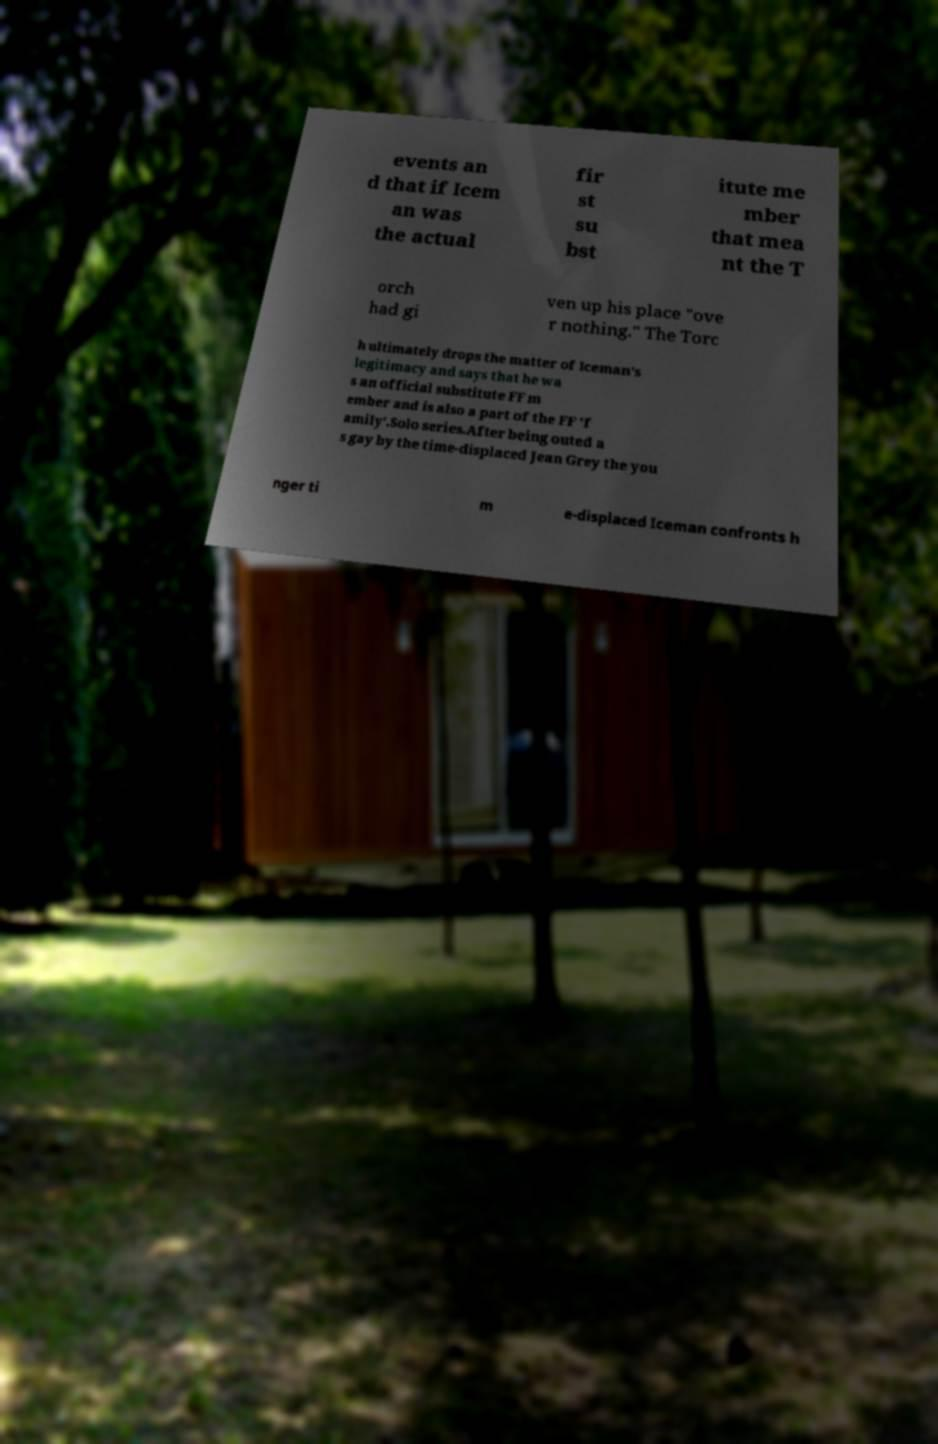Could you assist in decoding the text presented in this image and type it out clearly? events an d that if Icem an was the actual fir st su bst itute me mber that mea nt the T orch had gi ven up his place "ove r nothing." The Torc h ultimately drops the matter of Iceman's legitimacy and says that he wa s an official substitute FF m ember and is also a part of the FF 'f amily'.Solo series.After being outed a s gay by the time-displaced Jean Grey the you nger ti m e-displaced Iceman confronts h 